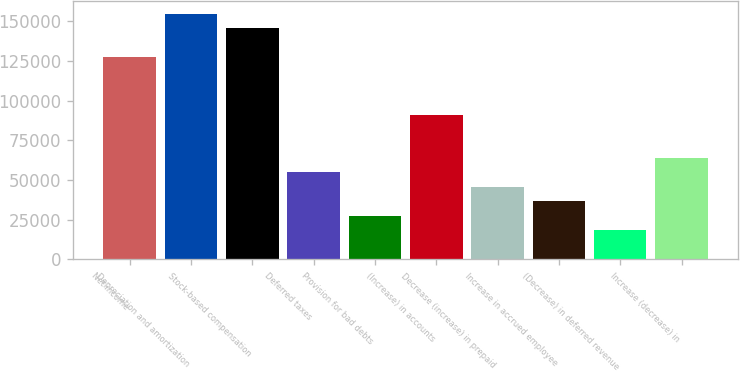Convert chart to OTSL. <chart><loc_0><loc_0><loc_500><loc_500><bar_chart><fcel>Net income<fcel>Depreciation and amortization<fcel>Stock-based compensation<fcel>Deferred taxes<fcel>Provision for bad debts<fcel>(Increase) in accounts<fcel>Decrease (increase) in prepaid<fcel>Increase in accrued employee<fcel>(Decrease) in deferred revenue<fcel>Increase (decrease) in<nl><fcel>127473<fcel>154732<fcel>145645<fcel>54781.4<fcel>27522.2<fcel>91127<fcel>45695<fcel>36608.6<fcel>18435.8<fcel>63867.8<nl></chart> 